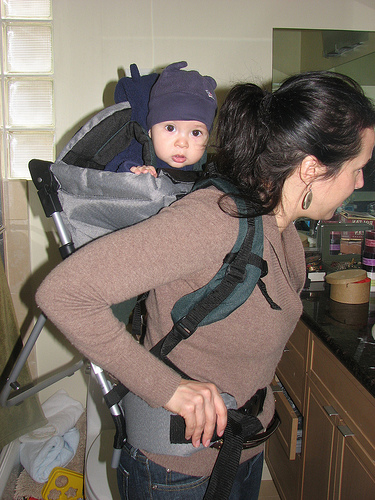<image>
Is the child behind the mother? Yes. From this viewpoint, the child is positioned behind the mother, with the mother partially or fully occluding the child. Is the child behind the women? Yes. From this viewpoint, the child is positioned behind the women, with the women partially or fully occluding the child. Is there a box on the baby? No. The box is not positioned on the baby. They may be near each other, but the box is not supported by or resting on top of the baby. 